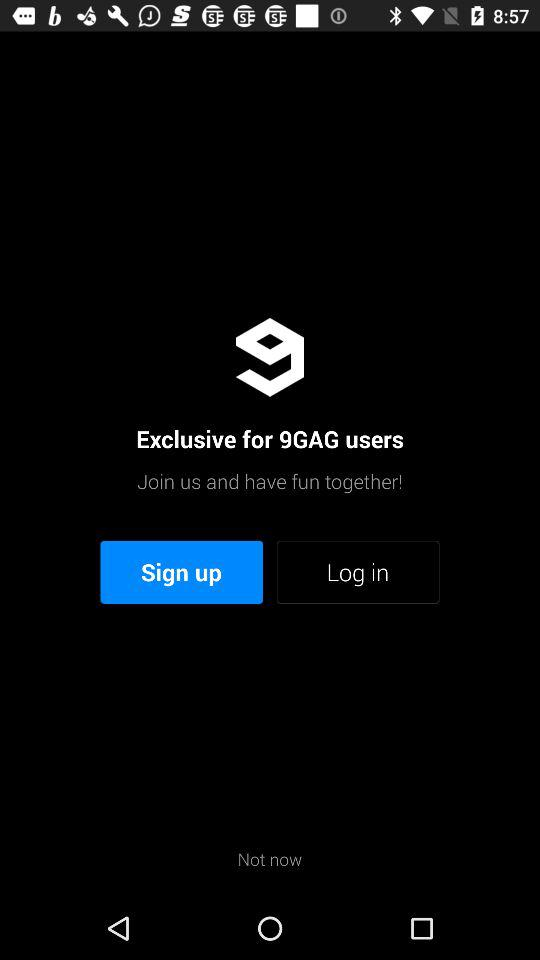What is the user name?
When the provided information is insufficient, respond with <no answer>. <no answer> 